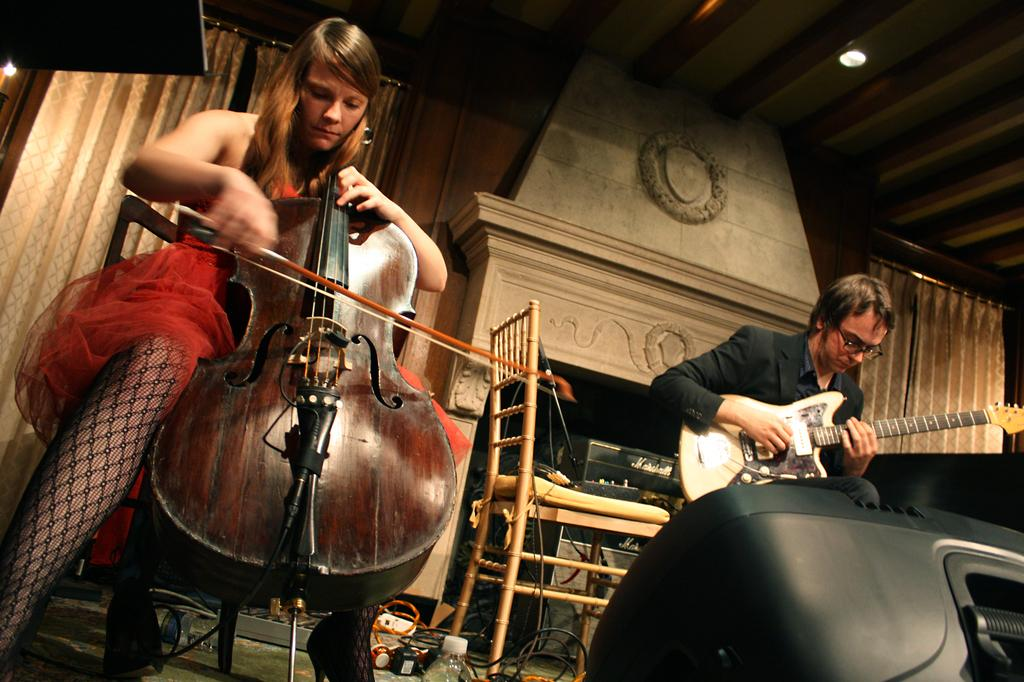What is the woman in the image doing? The woman is sitting in a chair and playing a violin. What is the man in the image doing? The man is sitting in a chair and playing a guitar. What objects can be seen in the background of the image? There is a speaker, a chair, cables, and a bottle in the background. What type of cable is the scarecrow holding in the image? There is no scarecrow or cable present in the image. How does the woman look at the man while playing the violin? The image does not show the woman looking at the man, so it cannot be determined from the image. 